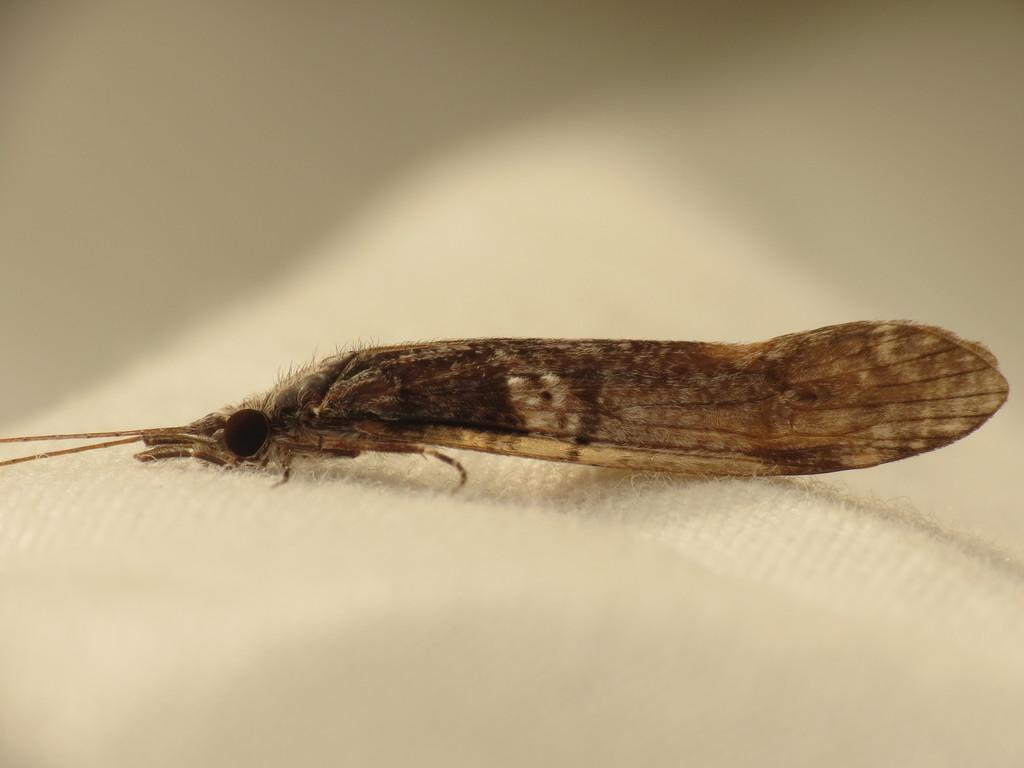What type of creature is present in the image? There is an insect in the image. Where is the insect located? The insect is on a white cloth. What type of jam is the insect spreading on the vest in the image? There is no vest or jam present in the image; it only features an insect on a white cloth. 